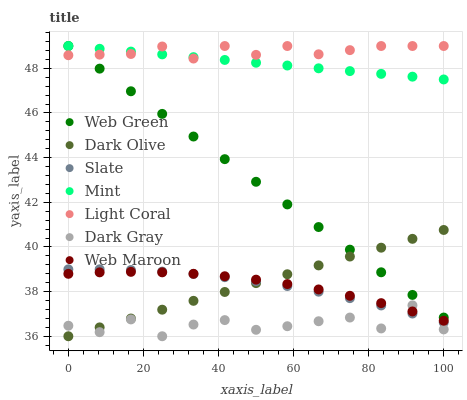Does Dark Gray have the minimum area under the curve?
Answer yes or no. Yes. Does Light Coral have the maximum area under the curve?
Answer yes or no. Yes. Does Slate have the minimum area under the curve?
Answer yes or no. No. Does Slate have the maximum area under the curve?
Answer yes or no. No. Is Mint the smoothest?
Answer yes or no. Yes. Is Dark Gray the roughest?
Answer yes or no. Yes. Is Slate the smoothest?
Answer yes or no. No. Is Slate the roughest?
Answer yes or no. No. Does Dark Gray have the lowest value?
Answer yes or no. Yes. Does Slate have the lowest value?
Answer yes or no. No. Does Mint have the highest value?
Answer yes or no. Yes. Does Slate have the highest value?
Answer yes or no. No. Is Dark Olive less than Mint?
Answer yes or no. Yes. Is Mint greater than Dark Gray?
Answer yes or no. Yes. Does Dark Olive intersect Slate?
Answer yes or no. Yes. Is Dark Olive less than Slate?
Answer yes or no. No. Is Dark Olive greater than Slate?
Answer yes or no. No. Does Dark Olive intersect Mint?
Answer yes or no. No. 